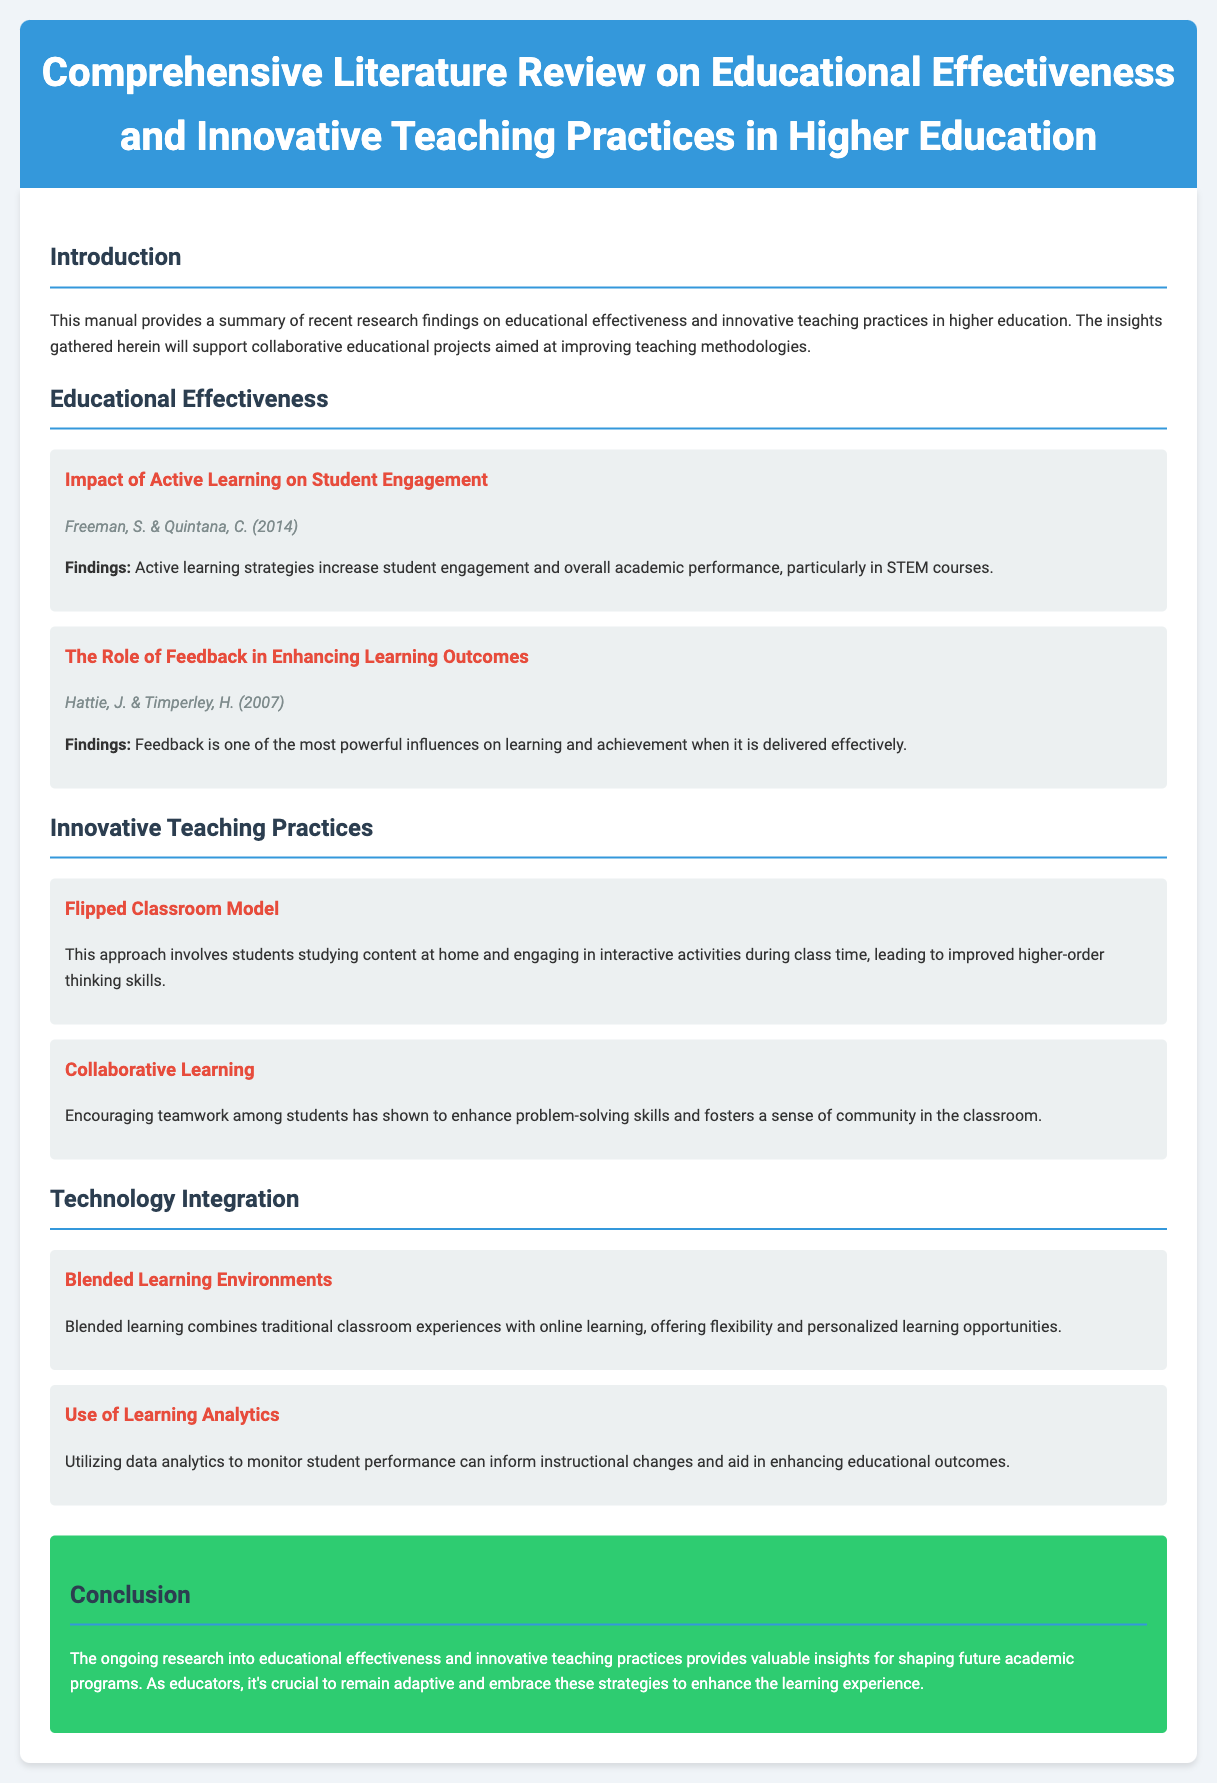What is the title of the manual? The title of the manual is found at the top of the document, indicating its focus on educational research.
Answer: Comprehensive Literature Review on Educational Effectiveness and Innovative Teaching Practices in Higher Education Who are the authors of the study on active learning? The authors' names are specified under the study section relating to active learning, providing credit for their findings.
Answer: Freeman, S. & Quintana, C What innovative teaching practice involves studying content at home? This practice is described in the document and outlines a specific model used in education.
Answer: Flipped Classroom Model What is the conclusion about educational effectiveness and innovative teaching practices? The conclusion summarizes the overall findings of the research and suggests an adaptive approach to education.
Answer: Valuable insights for shaping future academic programs Which initiative utilizes data analytics? This initiative focuses on the application of analytics in education, as mentioned in the technology integration section.
Answer: Use of Learning Analytics How many studies are mentioned under Educational Effectiveness? The number indicates the quantity of research studies referenced in this section of the document.
Answer: Two 